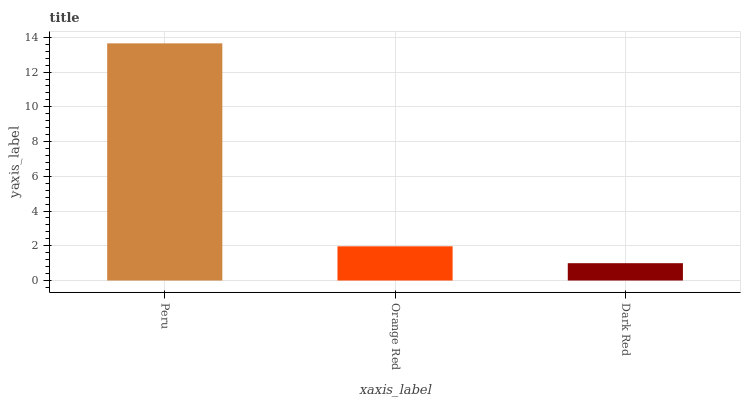Is Dark Red the minimum?
Answer yes or no. Yes. Is Peru the maximum?
Answer yes or no. Yes. Is Orange Red the minimum?
Answer yes or no. No. Is Orange Red the maximum?
Answer yes or no. No. Is Peru greater than Orange Red?
Answer yes or no. Yes. Is Orange Red less than Peru?
Answer yes or no. Yes. Is Orange Red greater than Peru?
Answer yes or no. No. Is Peru less than Orange Red?
Answer yes or no. No. Is Orange Red the high median?
Answer yes or no. Yes. Is Orange Red the low median?
Answer yes or no. Yes. Is Peru the high median?
Answer yes or no. No. Is Peru the low median?
Answer yes or no. No. 